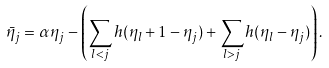Convert formula to latex. <formula><loc_0><loc_0><loc_500><loc_500>\bar { \eta } _ { j } = \alpha \eta _ { j } - \left ( \sum _ { l < j } h ( \eta _ { l } + 1 - \eta _ { j } ) + \sum _ { l > j } h ( \eta _ { l } - \eta _ { j } ) \right ) .</formula> 